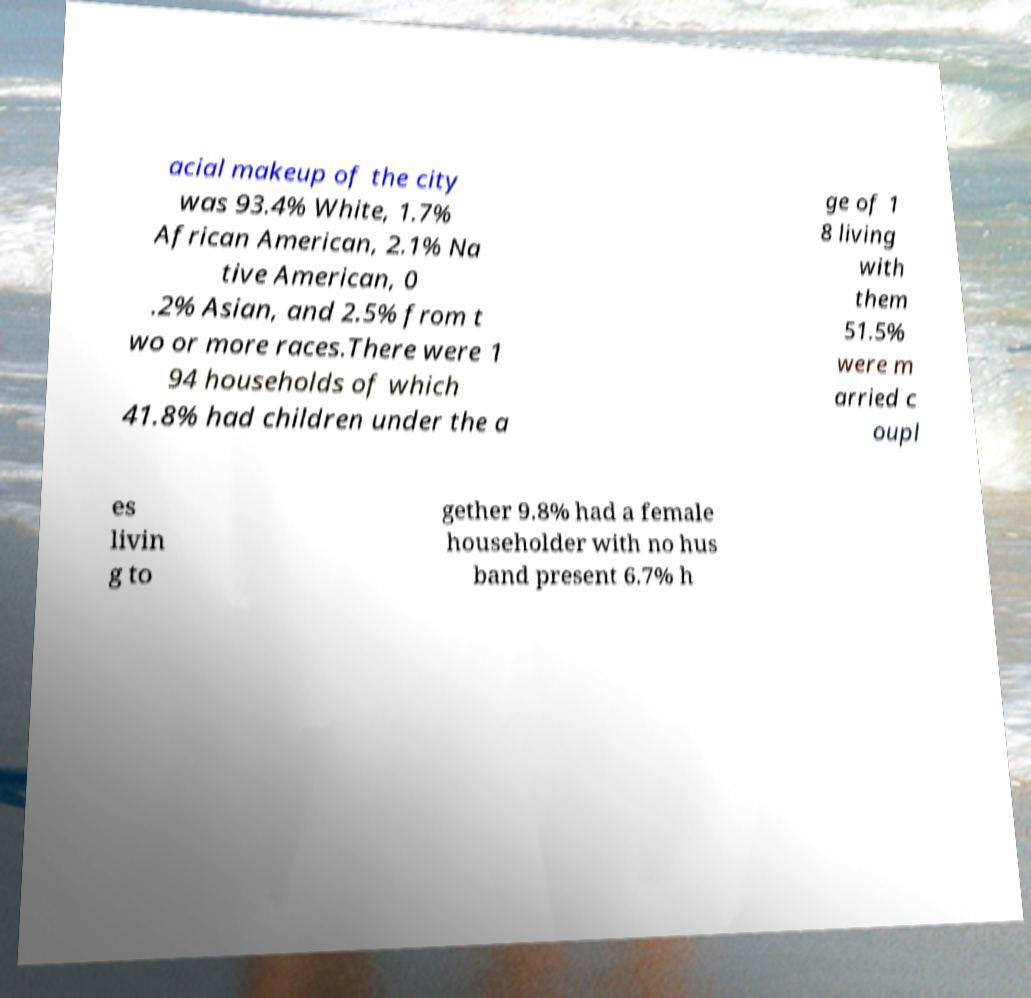What messages or text are displayed in this image? I need them in a readable, typed format. acial makeup of the city was 93.4% White, 1.7% African American, 2.1% Na tive American, 0 .2% Asian, and 2.5% from t wo or more races.There were 1 94 households of which 41.8% had children under the a ge of 1 8 living with them 51.5% were m arried c oupl es livin g to gether 9.8% had a female householder with no hus band present 6.7% h 